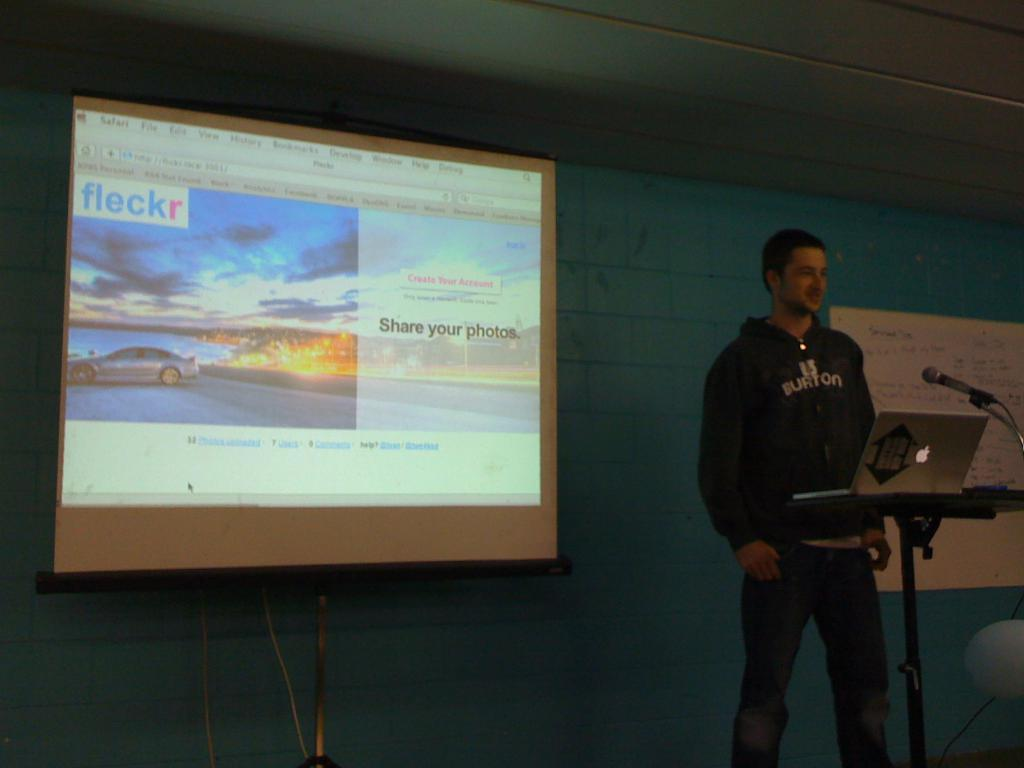<image>
Provide a brief description of the given image. A man stands in front a large presentation screen with Fleckr written in the top left. 